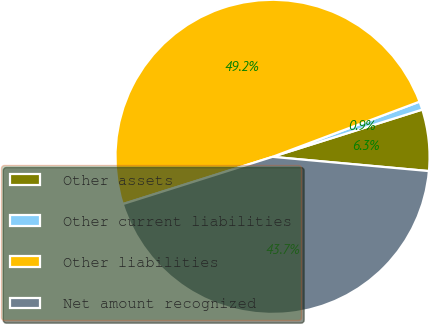<chart> <loc_0><loc_0><loc_500><loc_500><pie_chart><fcel>Other assets<fcel>Other current liabilities<fcel>Other liabilities<fcel>Net amount recognized<nl><fcel>6.31%<fcel>0.85%<fcel>49.15%<fcel>43.69%<nl></chart> 